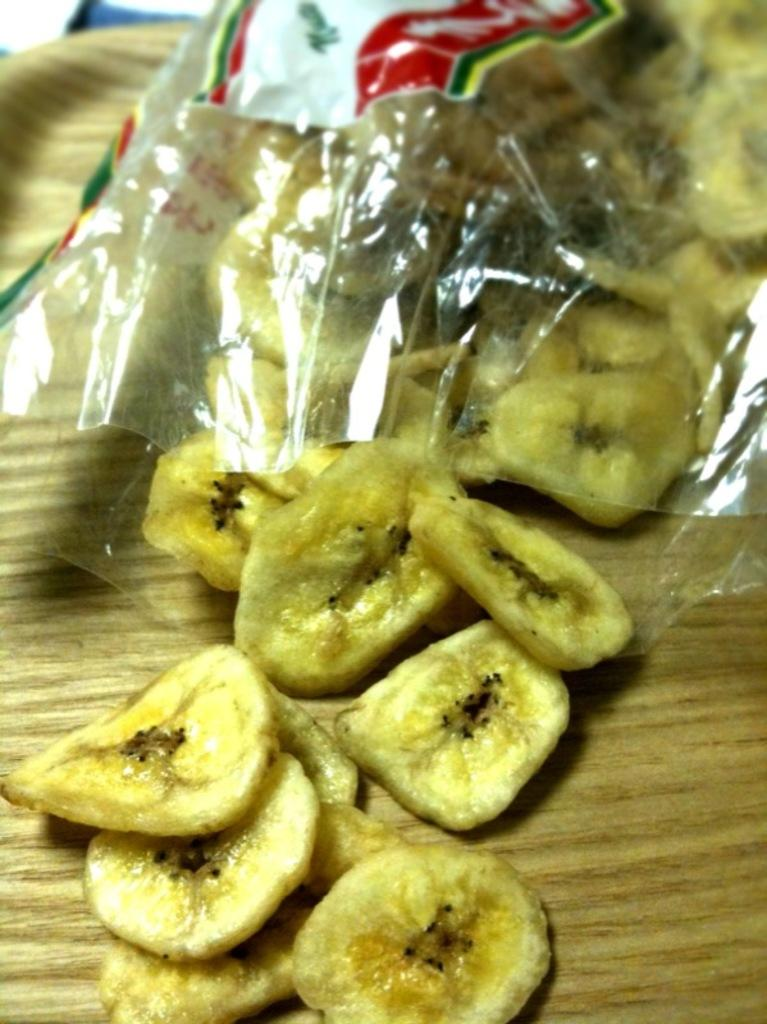What type of food is visible in the image? There are banana pieces in the image. What is covering the banana pieces in the image? There is a cover in the image. Where are the banana pieces and the cover located? Both the banana pieces and the cover are placed on a table. What type of goose can be seen sitting on the table in the image? There is no goose present in the image; it only features banana pieces and a cover on a table. How does the light affect the visibility of the banana pieces in the image? The image does not provide information about the lighting conditions, so it is not possible to determine how the light affects the visibility of the banana pieces. 